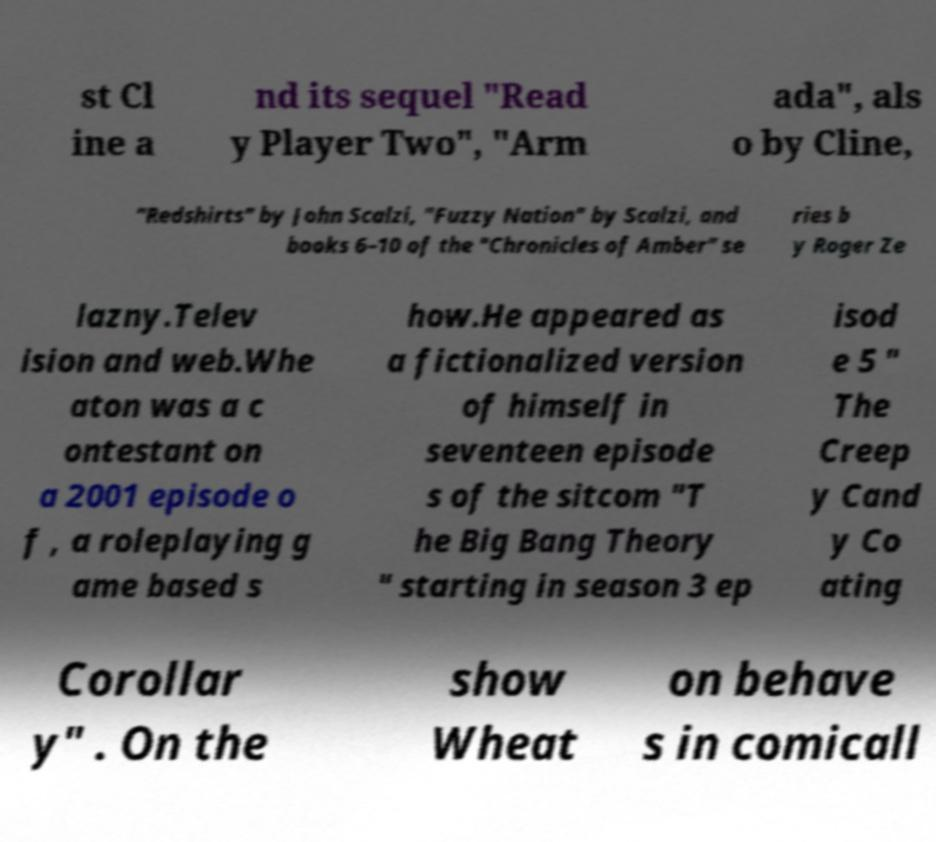Could you assist in decoding the text presented in this image and type it out clearly? st Cl ine a nd its sequel "Read y Player Two", "Arm ada", als o by Cline, "Redshirts" by John Scalzi, "Fuzzy Nation" by Scalzi, and books 6–10 of the "Chronicles of Amber" se ries b y Roger Ze lazny.Telev ision and web.Whe aton was a c ontestant on a 2001 episode o f , a roleplaying g ame based s how.He appeared as a fictionalized version of himself in seventeen episode s of the sitcom "T he Big Bang Theory " starting in season 3 ep isod e 5 " The Creep y Cand y Co ating Corollar y" . On the show Wheat on behave s in comicall 